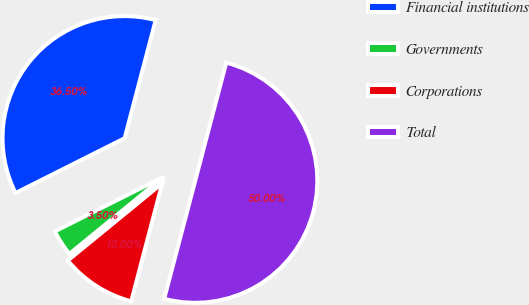Convert chart. <chart><loc_0><loc_0><loc_500><loc_500><pie_chart><fcel>Financial institutions<fcel>Governments<fcel>Corporations<fcel>Total<nl><fcel>36.5%<fcel>3.5%<fcel>10.0%<fcel>50.0%<nl></chart> 